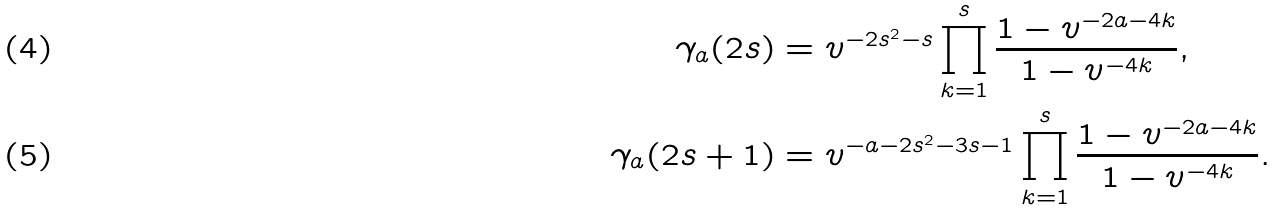<formula> <loc_0><loc_0><loc_500><loc_500>\gamma _ { a } ( 2 s ) & = v ^ { - 2 s ^ { 2 } - s } \prod _ { k = 1 } ^ { s } \frac { 1 - v ^ { - 2 a - 4 k } } { 1 - v ^ { - 4 k } } , \\ \gamma _ { a } ( 2 s + 1 ) & = v ^ { - a - 2 s ^ { 2 } - 3 s - 1 } \prod _ { k = 1 } ^ { s } \frac { 1 - v ^ { - 2 a - 4 k } } { 1 - v ^ { - 4 k } } .</formula> 